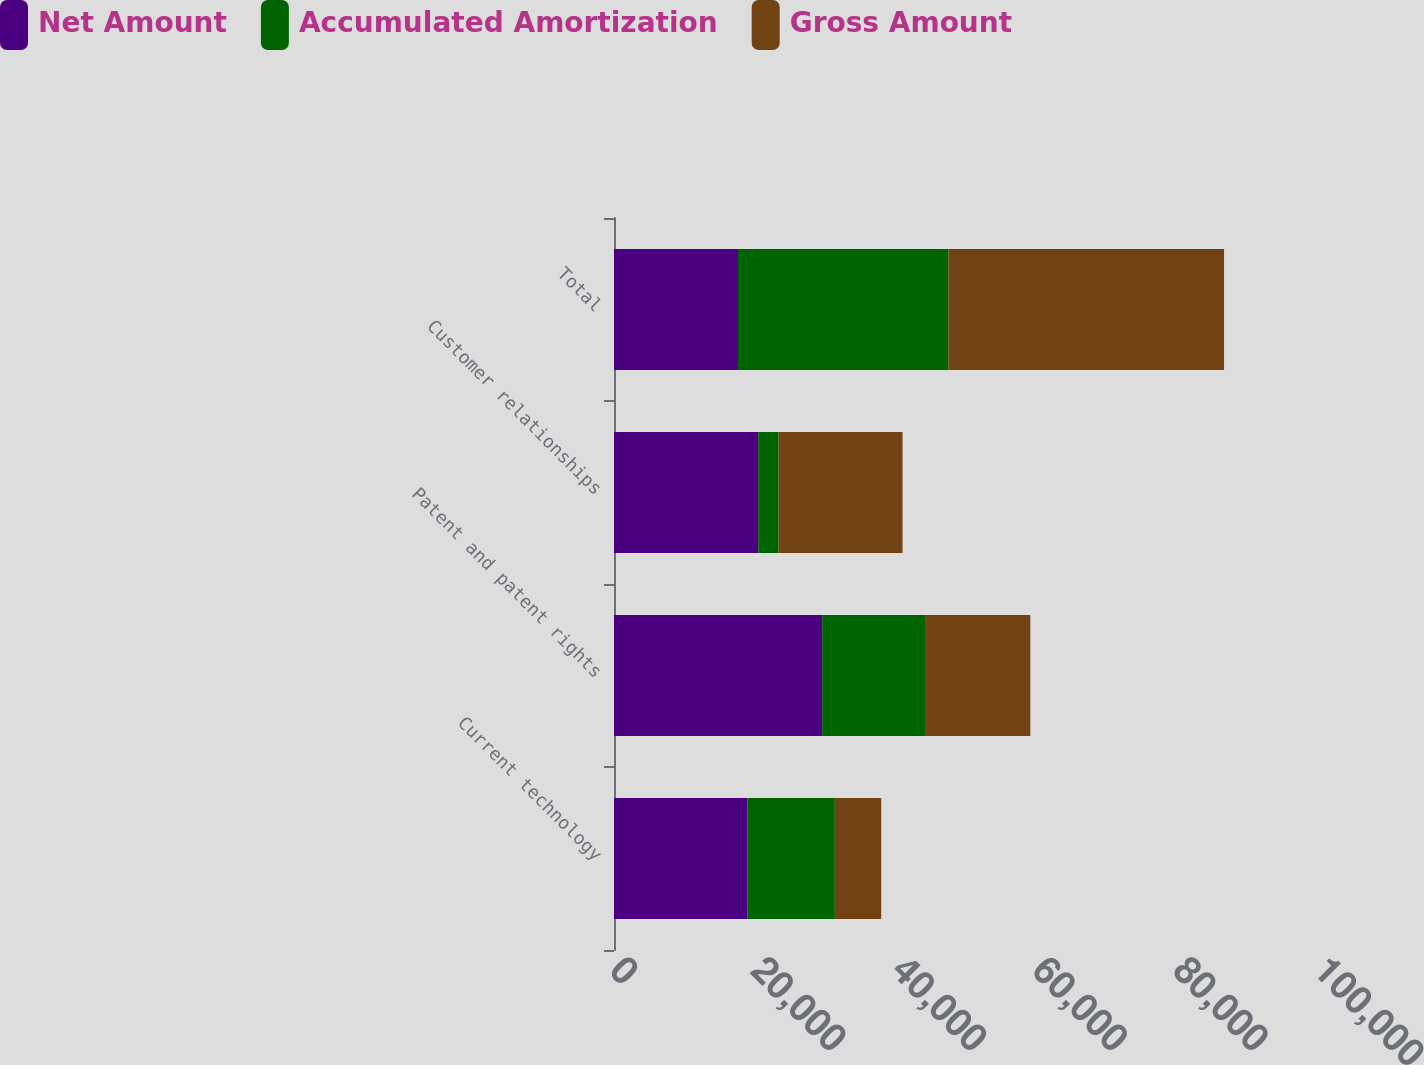Convert chart. <chart><loc_0><loc_0><loc_500><loc_500><stacked_bar_chart><ecel><fcel>Current technology<fcel>Patent and patent rights<fcel>Customer relationships<fcel>Total<nl><fcel>Net Amount<fcel>18978<fcel>29569<fcel>20493<fcel>17613<nl><fcel>Accumulated Amortization<fcel>12391<fcel>14618<fcel>2880<fcel>29889<nl><fcel>Gross Amount<fcel>6587<fcel>14951<fcel>17613<fcel>39151<nl></chart> 